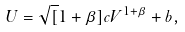Convert formula to latex. <formula><loc_0><loc_0><loc_500><loc_500>U = \sqrt { [ } 1 + \beta ] { c V ^ { 1 + \beta } + b } ,</formula> 